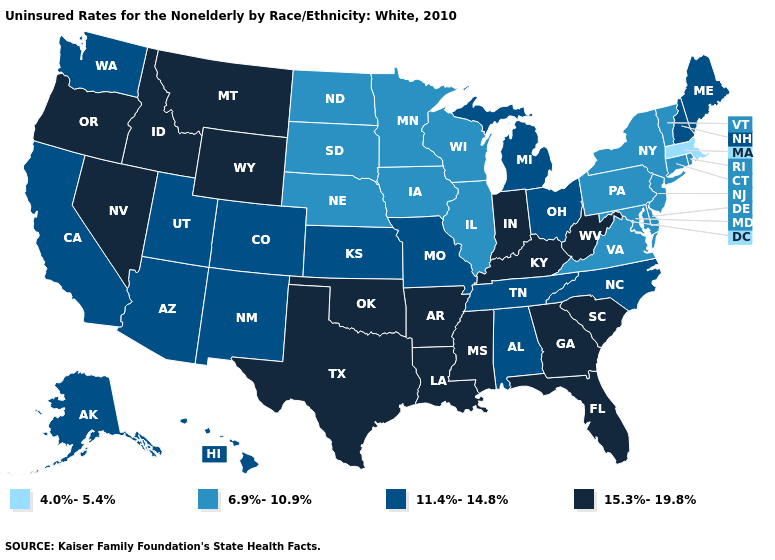Which states have the highest value in the USA?
Short answer required. Arkansas, Florida, Georgia, Idaho, Indiana, Kentucky, Louisiana, Mississippi, Montana, Nevada, Oklahoma, Oregon, South Carolina, Texas, West Virginia, Wyoming. How many symbols are there in the legend?
Write a very short answer. 4. Does Pennsylvania have a higher value than New York?
Quick response, please. No. What is the highest value in the South ?
Be succinct. 15.3%-19.8%. Does Tennessee have the lowest value in the South?
Be succinct. No. Name the states that have a value in the range 11.4%-14.8%?
Quick response, please. Alabama, Alaska, Arizona, California, Colorado, Hawaii, Kansas, Maine, Michigan, Missouri, New Hampshire, New Mexico, North Carolina, Ohio, Tennessee, Utah, Washington. Which states have the lowest value in the MidWest?
Answer briefly. Illinois, Iowa, Minnesota, Nebraska, North Dakota, South Dakota, Wisconsin. Among the states that border Utah , does New Mexico have the lowest value?
Keep it brief. Yes. Name the states that have a value in the range 4.0%-5.4%?
Short answer required. Massachusetts. Does North Carolina have the highest value in the South?
Answer briefly. No. Does Pennsylvania have a lower value than Colorado?
Be succinct. Yes. Name the states that have a value in the range 6.9%-10.9%?
Concise answer only. Connecticut, Delaware, Illinois, Iowa, Maryland, Minnesota, Nebraska, New Jersey, New York, North Dakota, Pennsylvania, Rhode Island, South Dakota, Vermont, Virginia, Wisconsin. Name the states that have a value in the range 15.3%-19.8%?
Short answer required. Arkansas, Florida, Georgia, Idaho, Indiana, Kentucky, Louisiana, Mississippi, Montana, Nevada, Oklahoma, Oregon, South Carolina, Texas, West Virginia, Wyoming. Does Montana have the highest value in the USA?
Concise answer only. Yes. What is the value of New Mexico?
Answer briefly. 11.4%-14.8%. 